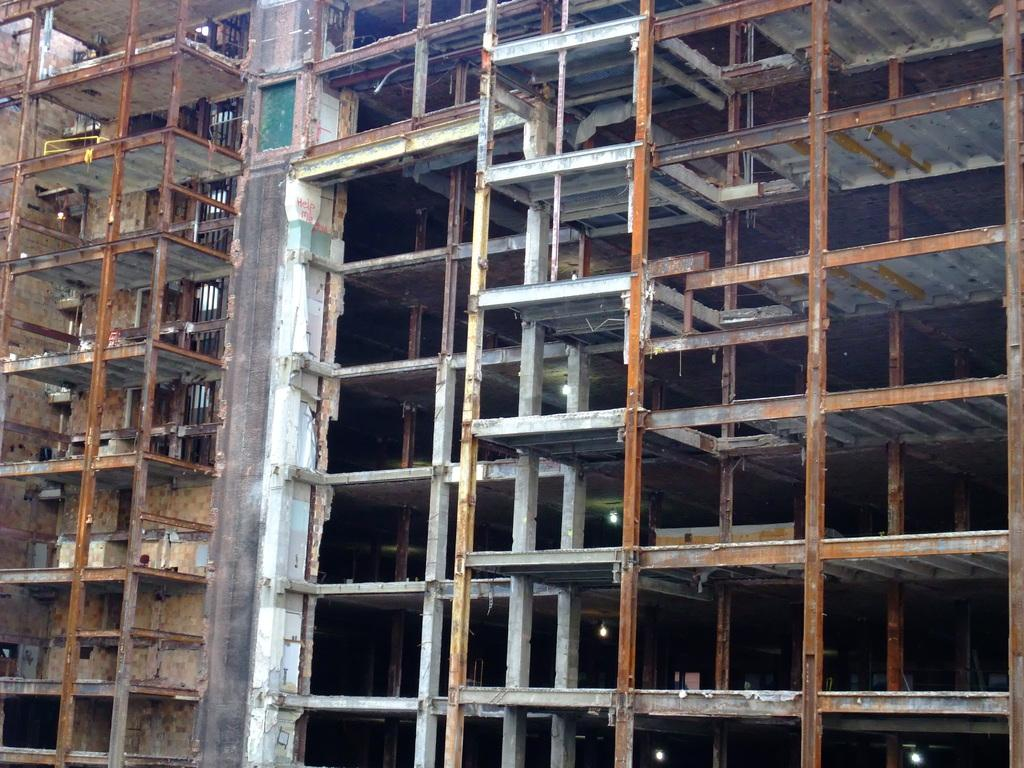What is happening in the image? The image shows the construction of a building. Can you describe the scene in more detail? The construction site includes various equipment, materials, and workers involved in the building process. What stage of construction might be depicted in the image? It is difficult to determine the exact stage of construction from the image alone, but it appears to be an active construction site. How many people are sleeping in their underwear at the construction site in the image? There is no information about people sleeping or wearing underwear in the image; it shows the construction of a building. 